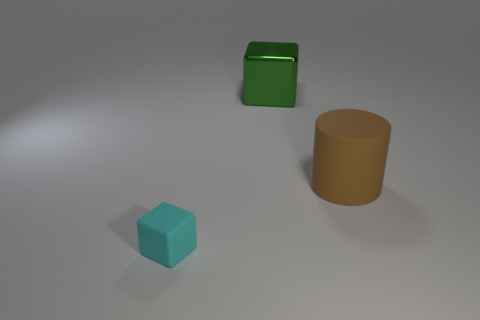Does the green thing have the same size as the cyan thing?
Offer a terse response. No. There is a rubber object that is left of the brown matte thing; are there any cyan things that are on the left side of it?
Your response must be concise. No. What is the shape of the big object that is in front of the big green metallic block?
Keep it short and to the point. Cylinder. How many rubber things are to the left of the cube in front of the brown matte thing that is right of the big green block?
Provide a short and direct response. 0. Do the cyan rubber block and the cube that is behind the rubber cylinder have the same size?
Your answer should be very brief. No. There is a cube behind the cube that is in front of the cylinder; how big is it?
Your response must be concise. Large. How many other tiny cyan blocks are made of the same material as the cyan cube?
Your response must be concise. 0. Is there a tiny red shiny thing?
Make the answer very short. No. What is the size of the block that is on the right side of the tiny block?
Your response must be concise. Large. What number of other large cylinders have the same color as the rubber cylinder?
Provide a succinct answer. 0. 